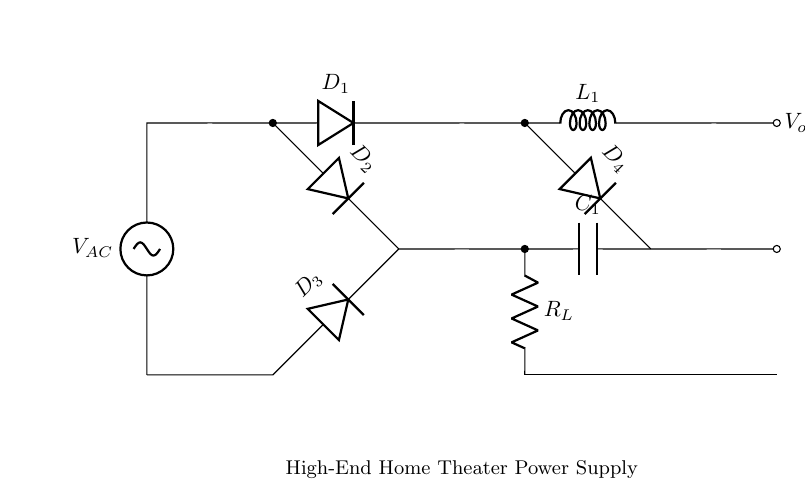What is the input voltage of the circuit? The input voltage is denoted as V_AC, which is labeled on the left side of the circuit diagram.
Answer: V_AC What is the role of diode D1? Diode D1 conducts during the positive half cycle of the AC input, allowing current to flow in one direction and thus converting AC to pulsating DC.
Answer: Rectification How many diodes are used in this rectifier circuit? By counting the diodes labeled as D1, D2, D3, and D4 on the circuit diagram, we find there are four diodes used in total.
Answer: 4 What component is responsible for filtering in this circuit? The capacitor labeled C1 is responsible for filtering the output, smoothing out the fluctuations in the pulsating DC.
Answer: C1 Where is the load resistor located in the circuit? The load resistor, labeled R_L, is located at the bottom branch of the circuit, connected to the output voltage node.
Answer: R_L What does the presence of the inductor L1 indicate about the circuit? The inductor L1 reduces the ripple in the output by storing energy when the current is high and releasing it when the current drops, indicating it may be used for further smoothing along with C1.
Answer: Smoothing 